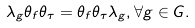<formula> <loc_0><loc_0><loc_500><loc_500>\lambda _ { g } \theta _ { f } \theta _ { \tau } = \theta _ { f } \theta _ { \tau } \lambda _ { g } , \forall g \in G .</formula> 